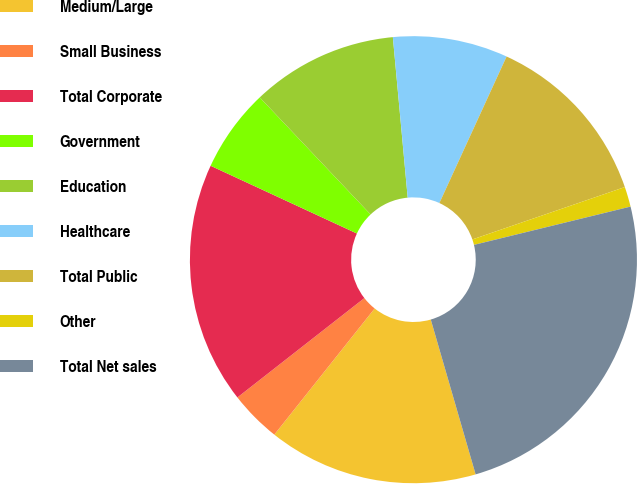Convert chart. <chart><loc_0><loc_0><loc_500><loc_500><pie_chart><fcel>Medium/Large<fcel>Small Business<fcel>Total Corporate<fcel>Government<fcel>Education<fcel>Healthcare<fcel>Total Public<fcel>Other<fcel>Total Net sales<nl><fcel>15.18%<fcel>3.74%<fcel>17.47%<fcel>6.03%<fcel>10.6%<fcel>8.31%<fcel>12.89%<fcel>1.45%<fcel>24.33%<nl></chart> 